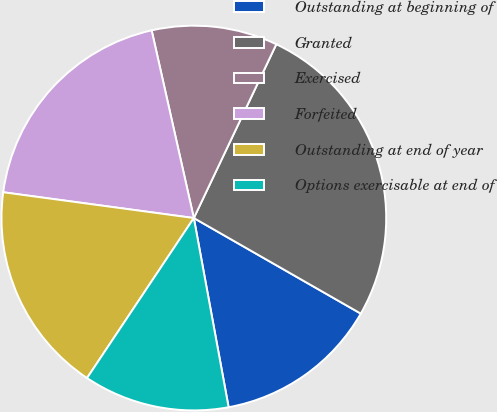Convert chart. <chart><loc_0><loc_0><loc_500><loc_500><pie_chart><fcel>Outstanding at beginning of<fcel>Granted<fcel>Exercised<fcel>Forfeited<fcel>Outstanding at end of year<fcel>Options exercisable at end of<nl><fcel>13.83%<fcel>26.22%<fcel>10.57%<fcel>19.34%<fcel>17.77%<fcel>12.26%<nl></chart> 